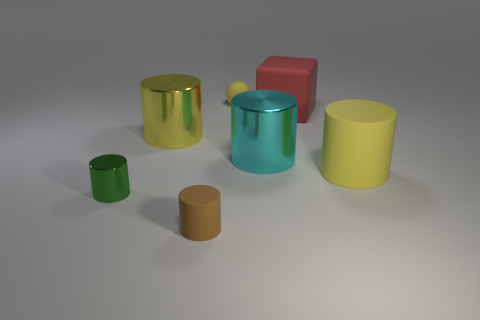Could you describe the positioning of the objects in terms of depth from the viewpoint? Certainly, when we analyze the image for depth perception, the objects appear to be arranged at varying distances. The brown cylinder is the closest to the viewpoint, while the large green matte ball seems to be the farthest. The cyan and yellow cylinders, along with the red cube, occupy the middle ground with regards to depth. 